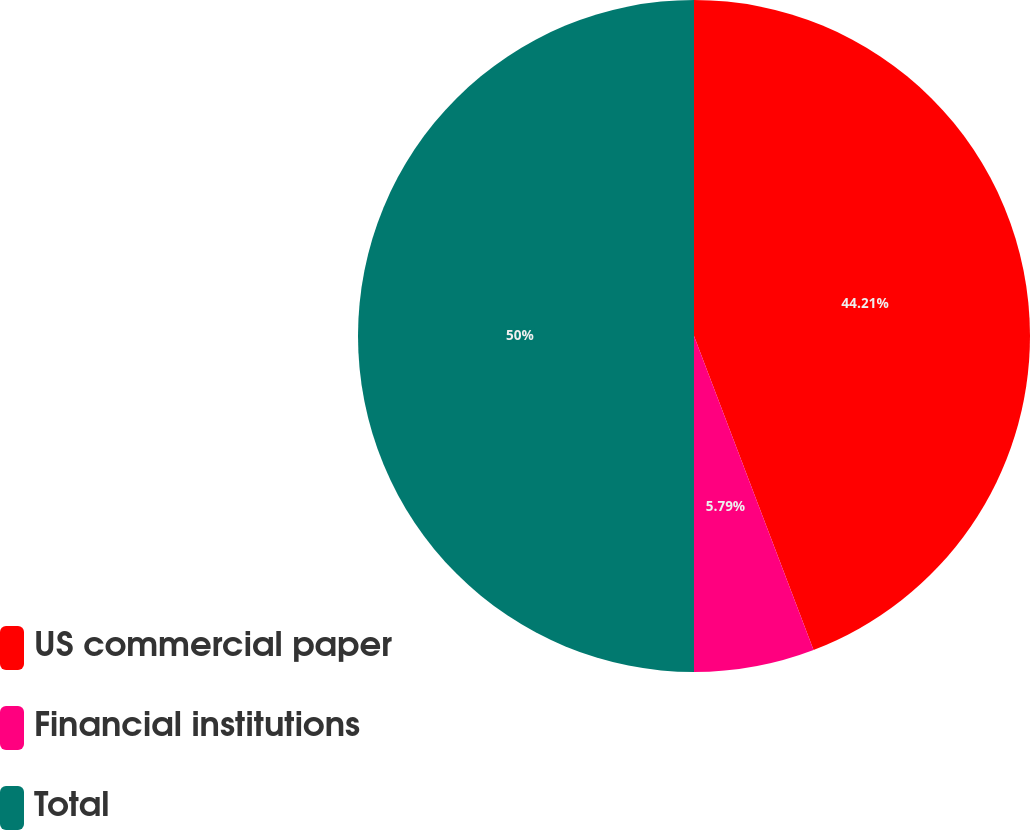<chart> <loc_0><loc_0><loc_500><loc_500><pie_chart><fcel>US commercial paper<fcel>Financial institutions<fcel>Total<nl><fcel>44.21%<fcel>5.79%<fcel>50.0%<nl></chart> 